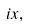Convert formula to latex. <formula><loc_0><loc_0><loc_500><loc_500>i x ,</formula> 